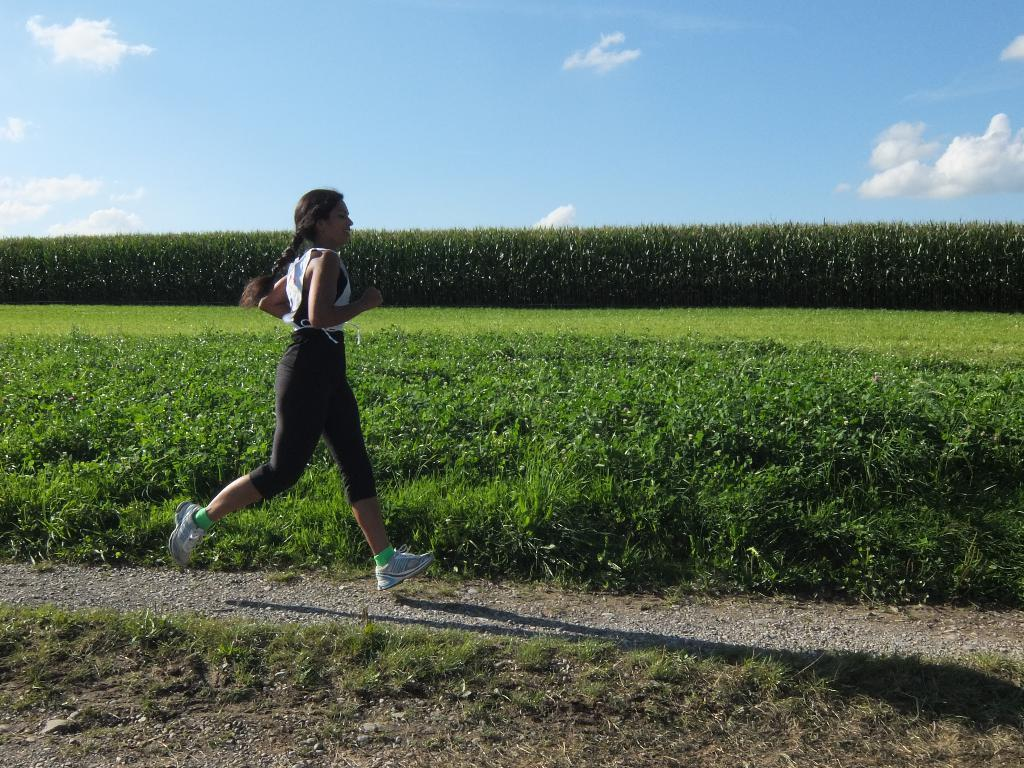Who is the main subject in the image? There is a girl in the image. What is the girl doing in the image? The girl is running on the ground. What can be seen in the background of the image? There are trees, plants, and the sky visible in the background of the image. What is the condition of the sky in the image? Clouds are present in the sky. What type of brass instrument is the girl playing in the image? There is no brass instrument present in the image; the girl is running on the ground. Is there a church visible in the background of the image? No, there is no church present in the image; the background includes trees, plants, and the sky. 